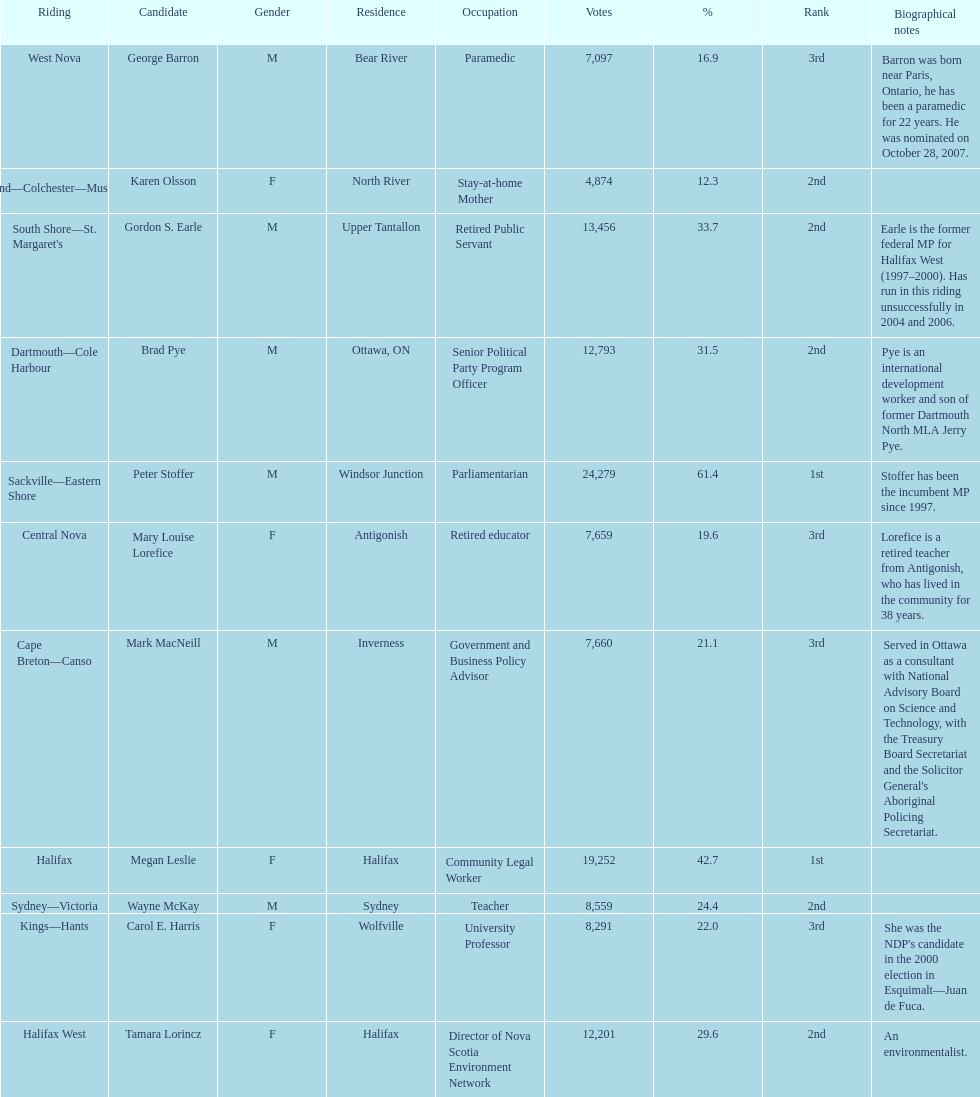What is the total of votes megan leslie secured? 19,252. 